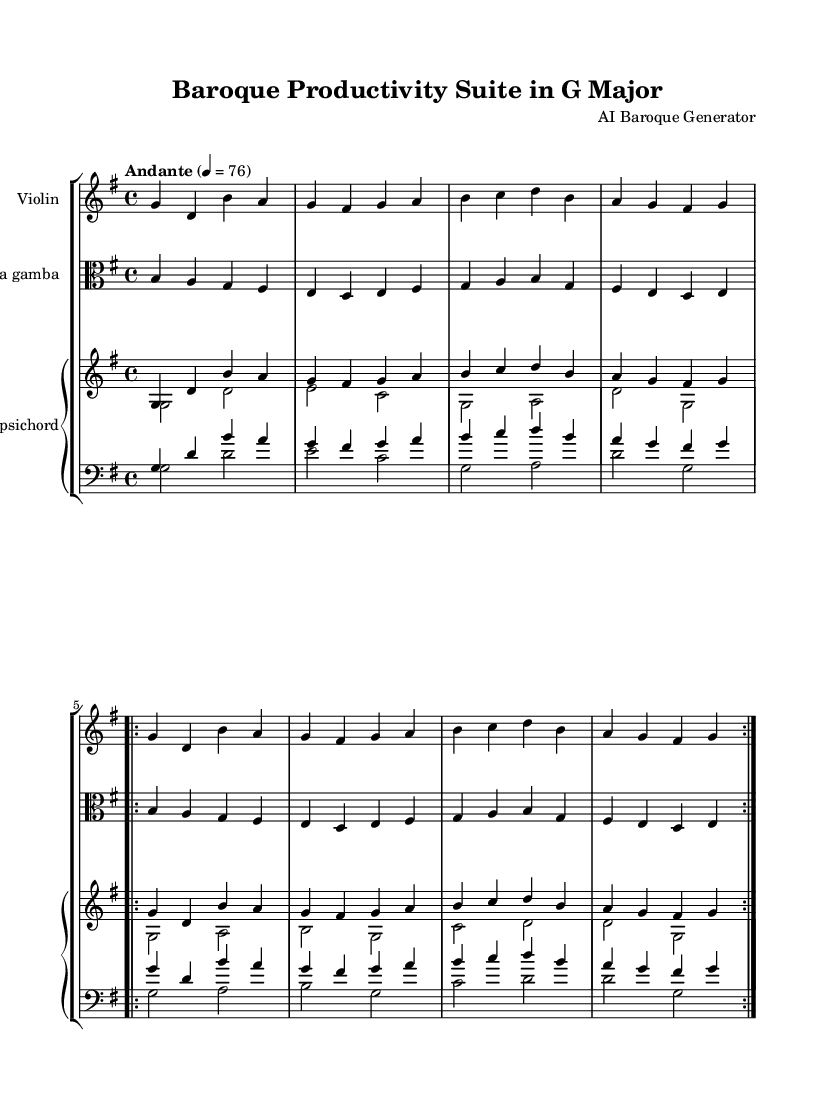What is the key signature of this music? The key signature is indicated by the number of sharps or flats in the music. In this case, the music is in G major, which has one sharp, F#.
Answer: G major What is the time signature of this music? The time signature shows how many beats are in each measure. Here, the time signature is 4/4, which means there are four beats in each measure and the quarter note gets one beat.
Answer: 4/4 What is the tempo marking indicated in the music? The tempo is noted at the beginning of the score and indicates the speed of the piece. It is marked "Andante," which suggests a walking pace.
Answer: Andante How many measures are in the repeated section? The repeated section is indicated by the volta signs, which show that the section is to be played twice. Each instance of this section consists of four measures.
Answer: 4 measures Which instruments are included in this Baroque chamber music? The score indicates the presence of a Violin, Viola da gamba, and Harpsichord, which are all standard in Baroque chamber ensembles.
Answer: Violin, Viola da gamba, Harpsichord What is the structure of the harpsichord part? The harpsichord part consists of two staves, one for the treble clef and one for the bass clef. This typical setup allows for both melody and harmony to be played simultaneously.
Answer: Two staves What stylistic features are common in this Baroque piece compared to other styles? Baroque music often features ornamentation, contrapuntal textures, and a clear phrasing structure, seen in the use of repetition and the distinct melodic lines in each instrument part.
Answer: Ornamentation, counterpoint 